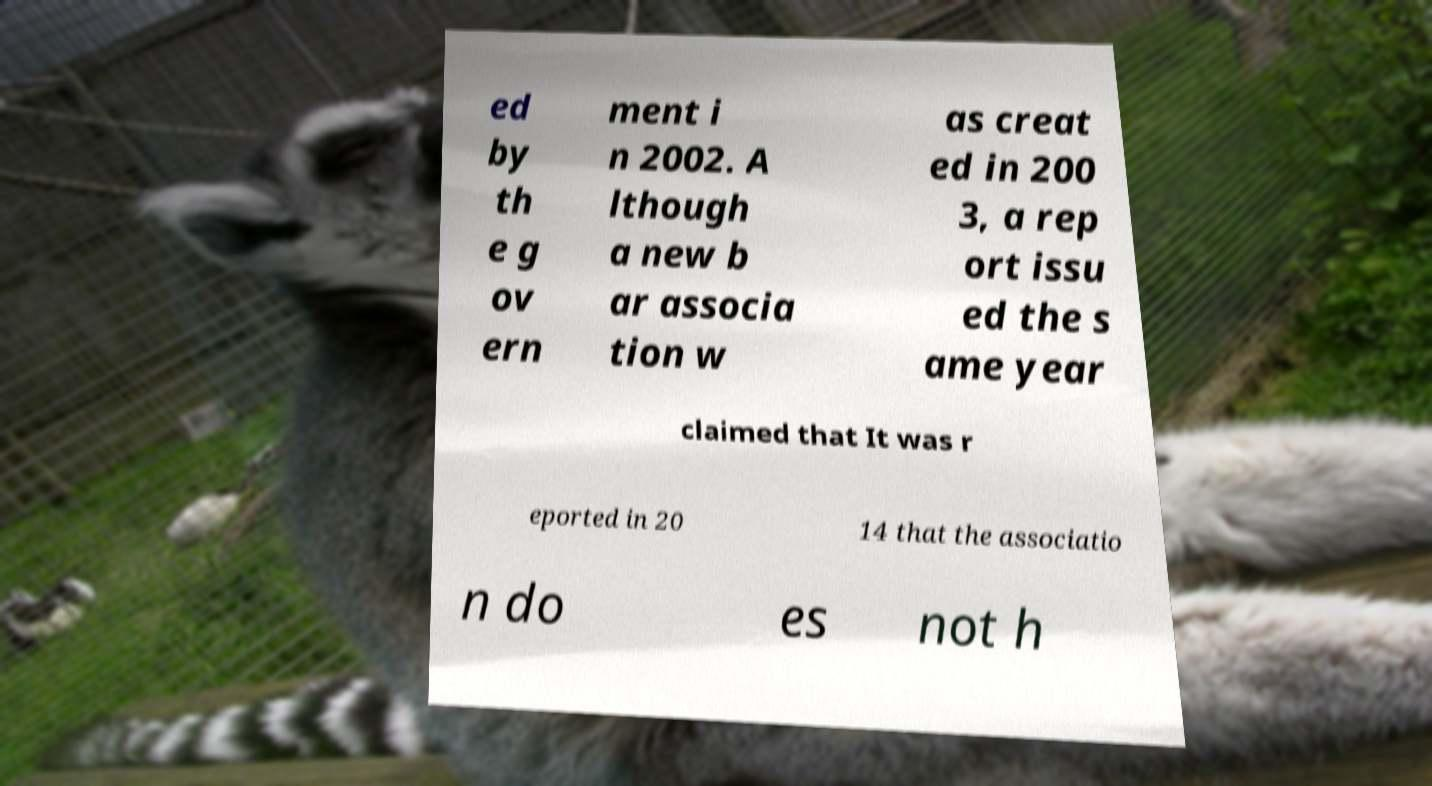Could you assist in decoding the text presented in this image and type it out clearly? ed by th e g ov ern ment i n 2002. A lthough a new b ar associa tion w as creat ed in 200 3, a rep ort issu ed the s ame year claimed that It was r eported in 20 14 that the associatio n do es not h 